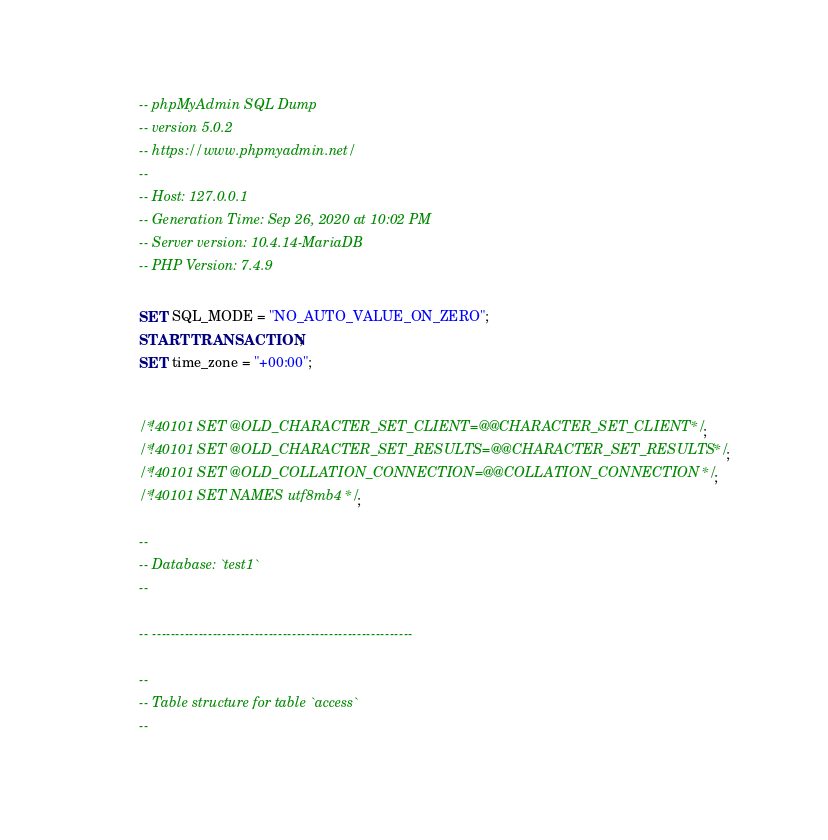<code> <loc_0><loc_0><loc_500><loc_500><_SQL_>-- phpMyAdmin SQL Dump
-- version 5.0.2
-- https://www.phpmyadmin.net/
--
-- Host: 127.0.0.1
-- Generation Time: Sep 26, 2020 at 10:02 PM
-- Server version: 10.4.14-MariaDB
-- PHP Version: 7.4.9

SET SQL_MODE = "NO_AUTO_VALUE_ON_ZERO";
START TRANSACTION;
SET time_zone = "+00:00";


/*!40101 SET @OLD_CHARACTER_SET_CLIENT=@@CHARACTER_SET_CLIENT */;
/*!40101 SET @OLD_CHARACTER_SET_RESULTS=@@CHARACTER_SET_RESULTS */;
/*!40101 SET @OLD_COLLATION_CONNECTION=@@COLLATION_CONNECTION */;
/*!40101 SET NAMES utf8mb4 */;

--
-- Database: `test1`
--

-- --------------------------------------------------------

--
-- Table structure for table `access`
--
</code> 